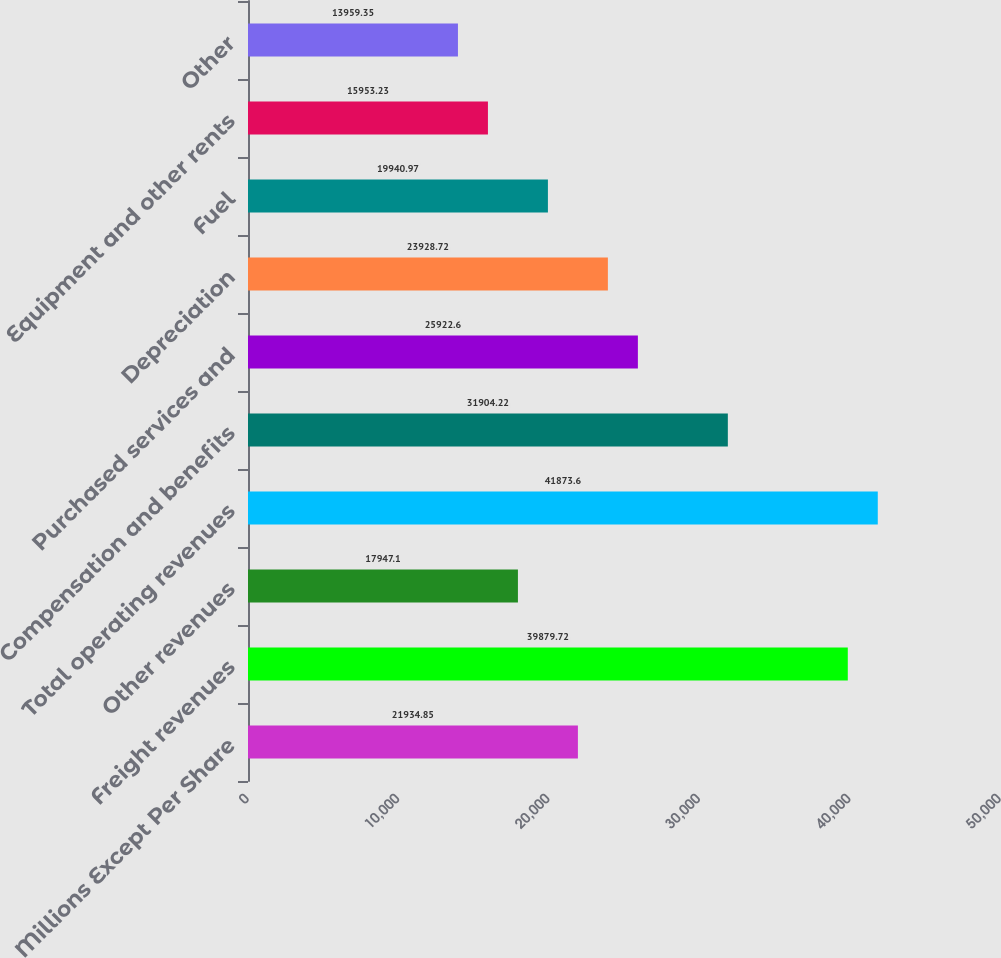<chart> <loc_0><loc_0><loc_500><loc_500><bar_chart><fcel>Millions Except Per Share<fcel>Freight revenues<fcel>Other revenues<fcel>Total operating revenues<fcel>Compensation and benefits<fcel>Purchased services and<fcel>Depreciation<fcel>Fuel<fcel>Equipment and other rents<fcel>Other<nl><fcel>21934.8<fcel>39879.7<fcel>17947.1<fcel>41873.6<fcel>31904.2<fcel>25922.6<fcel>23928.7<fcel>19941<fcel>15953.2<fcel>13959.4<nl></chart> 